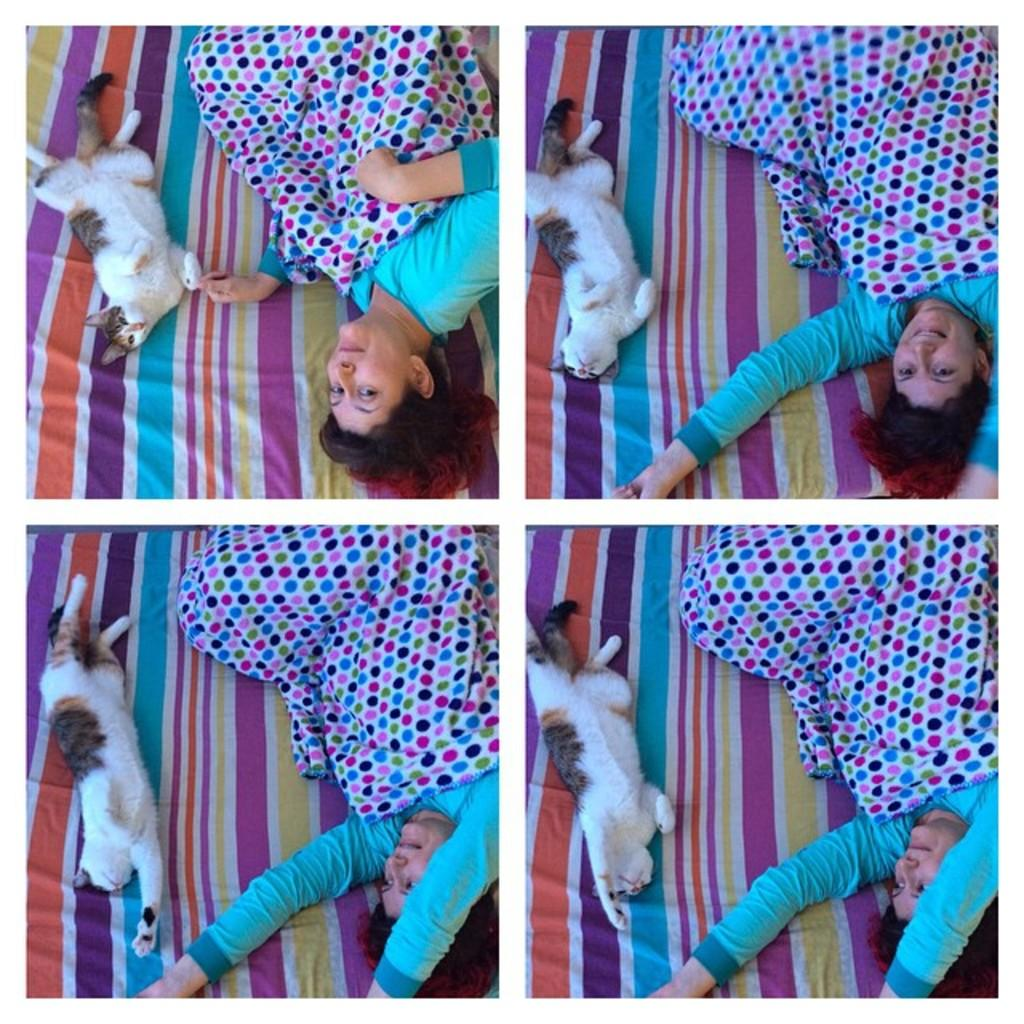How is the photo oriented in the image? The photo is upside down. How many images are present in the single frame? There are four images in a single frame. Can you describe one of the images? Yes, one of the images contains a cat. What is happening in another image? In another image, there is a woman sleeping. What type of meat is being cooked in one of the images? There is no image depicting meat being cooked; the images include a cat and a woman sleeping. What kind of plastic material is visible in one of the images? There is no plastic material visible in any of the images; they feature a cat and a woman sleeping. 